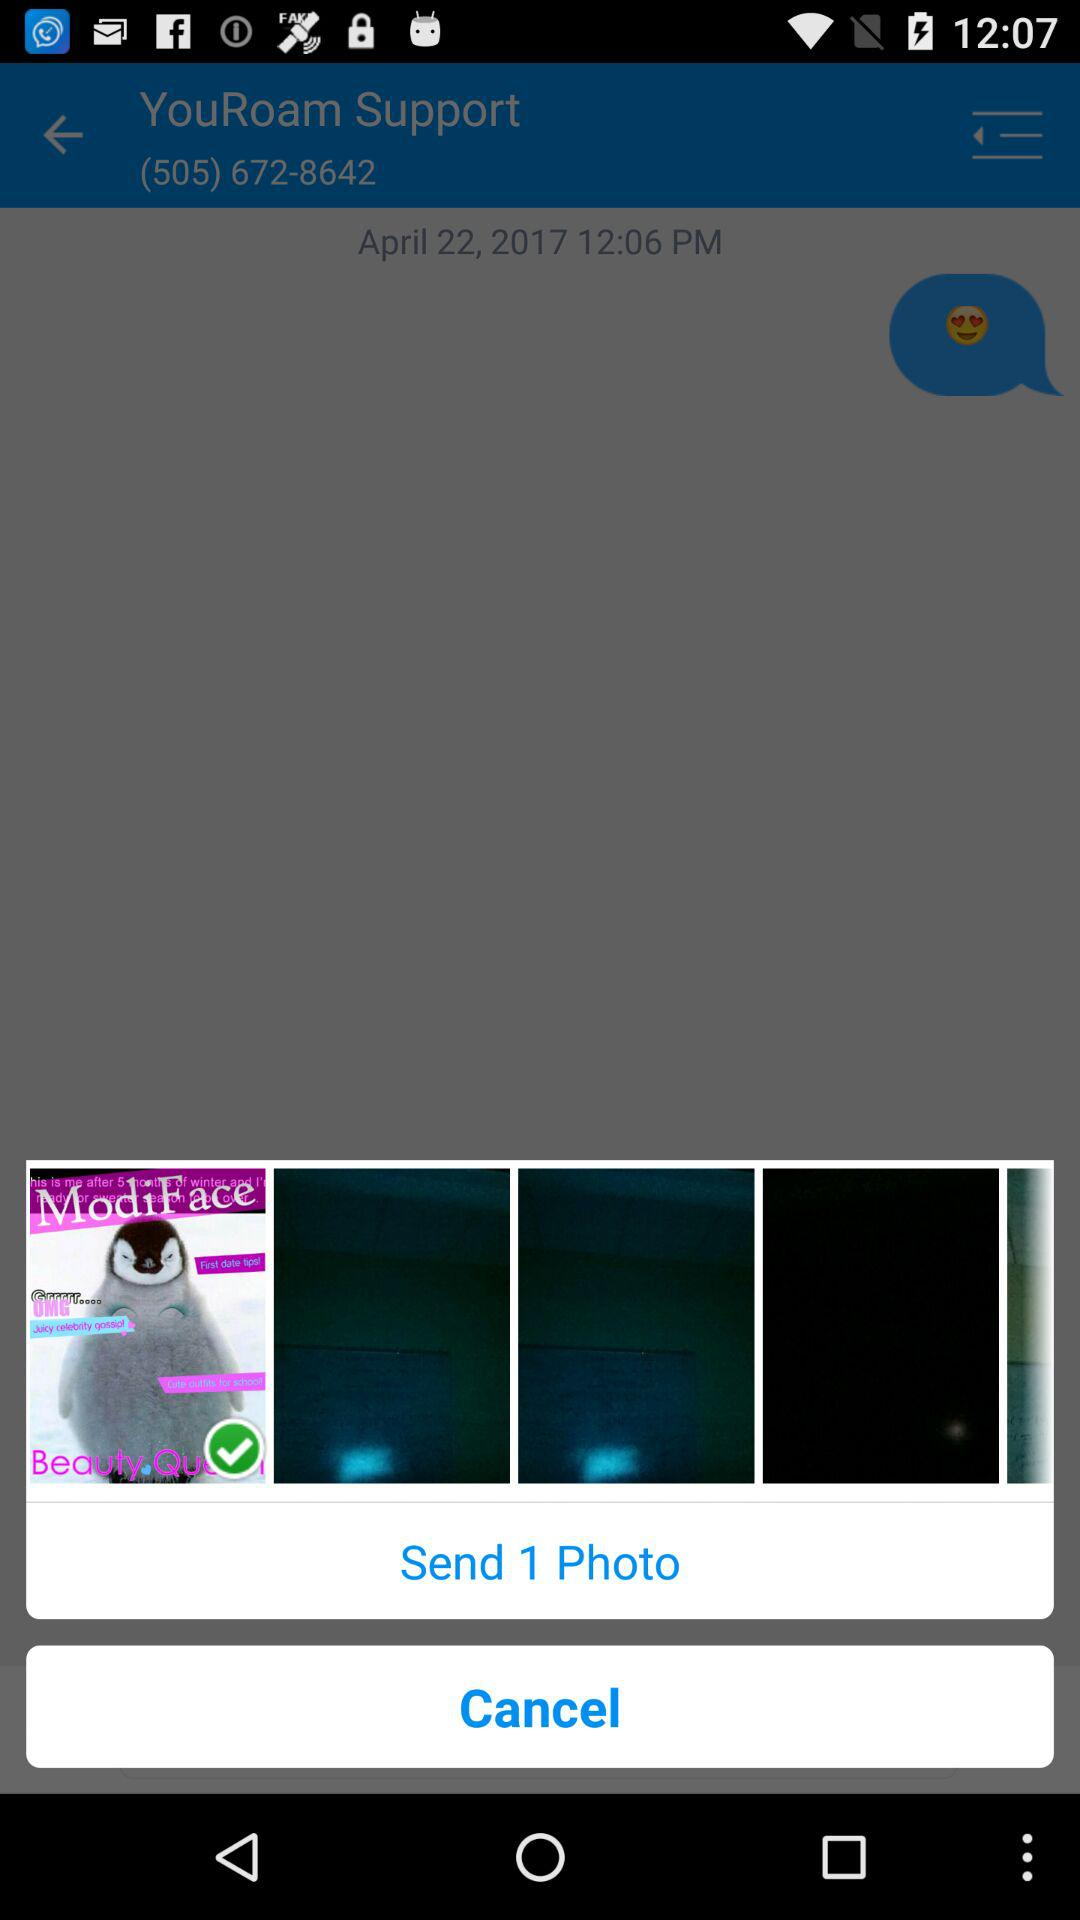What date is shown? The shown date is April 22, 2017. 